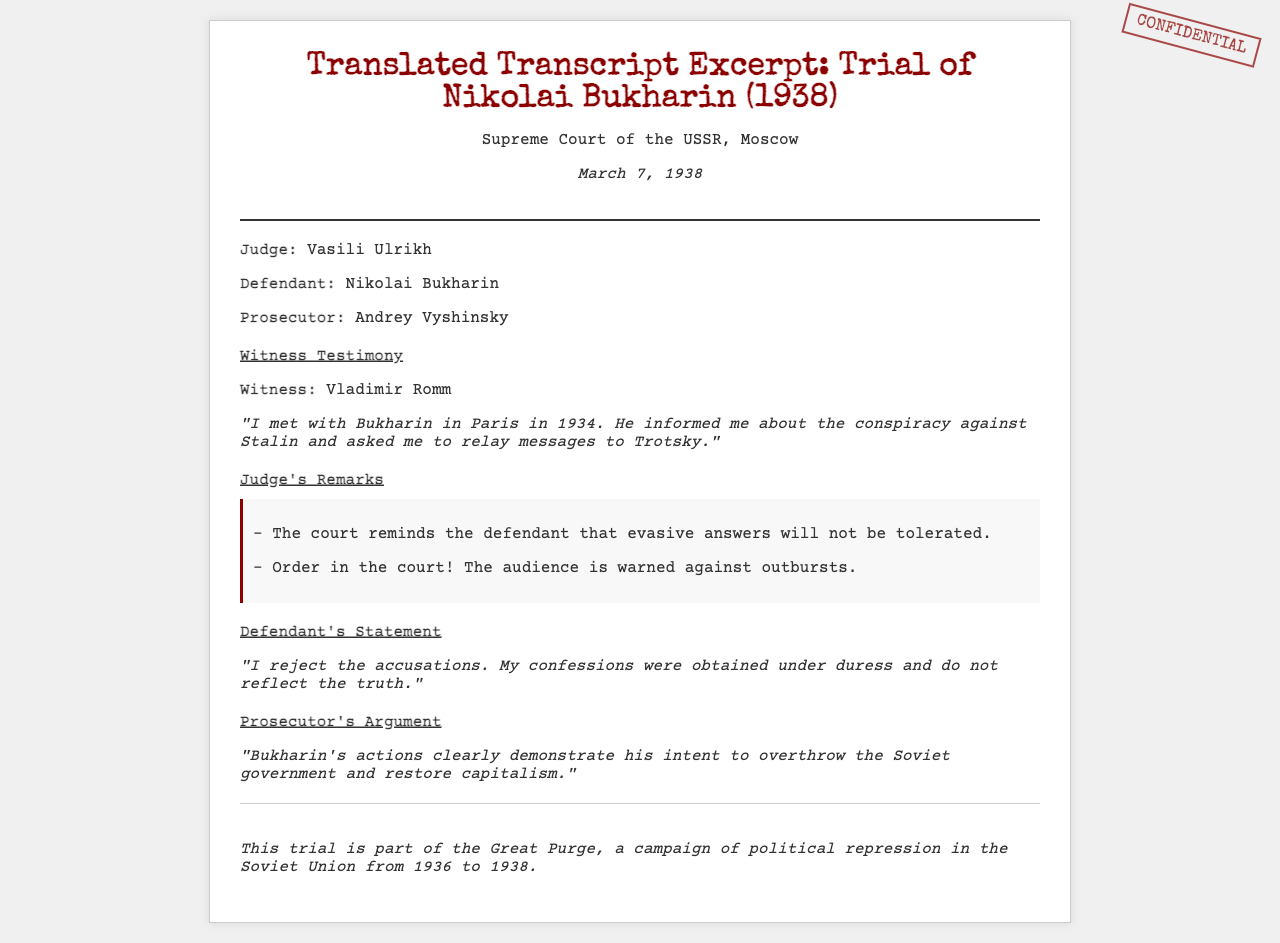What is the date of the trial? The date of the trial, as stated in the document, is March 7, 1938.
Answer: March 7, 1938 Who is the judge presiding over the trial? The judge presiding over the trial, as mentioned in the document, is Vasili Ulrikh.
Answer: Vasili Ulrikh What was Nikolai Bukharin accused of? The prosecutor argues that Bukharin's actions demonstrate his intent to overthrow the Soviet government and restore capitalism.
Answer: Overthrowing the Soviet government What did witness Vladimir Romm claim? Vladimir Romm testified that Bukharin informed him about a conspiracy against Stalin and asked him to relay messages to Trotsky.
Answer: A conspiracy against Stalin What did the judge remind the defendant? The judge reminded the defendant that evasive answers would not be tolerated during the trial.
Answer: Evasive answers will not be tolerated What type of trial is this document discussing? The trial is described as part of the Great Purge, a campaign of political repression in the Soviet Union.
Answer: Great Purge What did Bukharin say about his confessions? Bukharin claimed that his confessions were obtained under duress and do not reflect the truth.
Answer: Obtained under duress What was the role of Andrey Vyshinsky in the trial? Andrey Vyshinsky is identified in the document as the prosecutor in the trial.
Answer: Prosecutor 